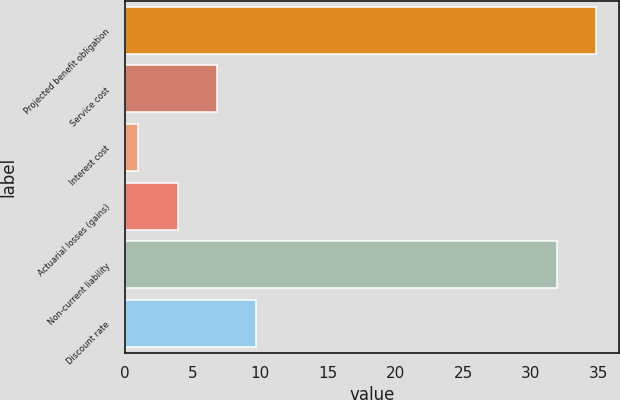Convert chart. <chart><loc_0><loc_0><loc_500><loc_500><bar_chart><fcel>Projected benefit obligation<fcel>Service cost<fcel>Interest cost<fcel>Actuarial losses (gains)<fcel>Non-current liability<fcel>Discount rate<nl><fcel>34.8<fcel>6.8<fcel>1<fcel>3.9<fcel>31.9<fcel>9.7<nl></chart> 